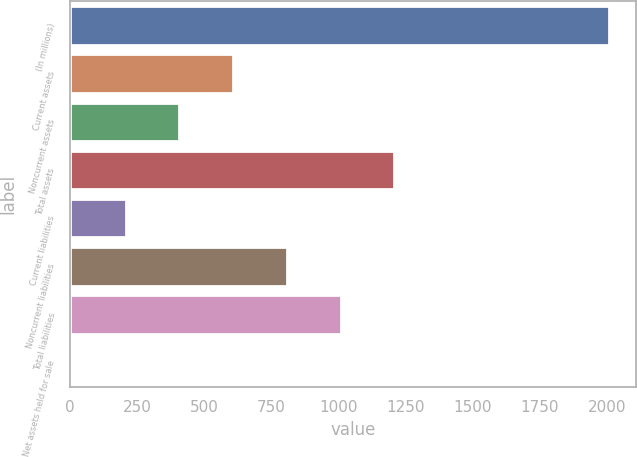Convert chart. <chart><loc_0><loc_0><loc_500><loc_500><bar_chart><fcel>(In millions)<fcel>Current assets<fcel>Noncurrent assets<fcel>Total assets<fcel>Current liabilities<fcel>Noncurrent liabilities<fcel>Total liabilities<fcel>Net assets held for sale<nl><fcel>2008<fcel>606.6<fcel>406.4<fcel>1207.2<fcel>206.2<fcel>806.8<fcel>1007<fcel>6<nl></chart> 